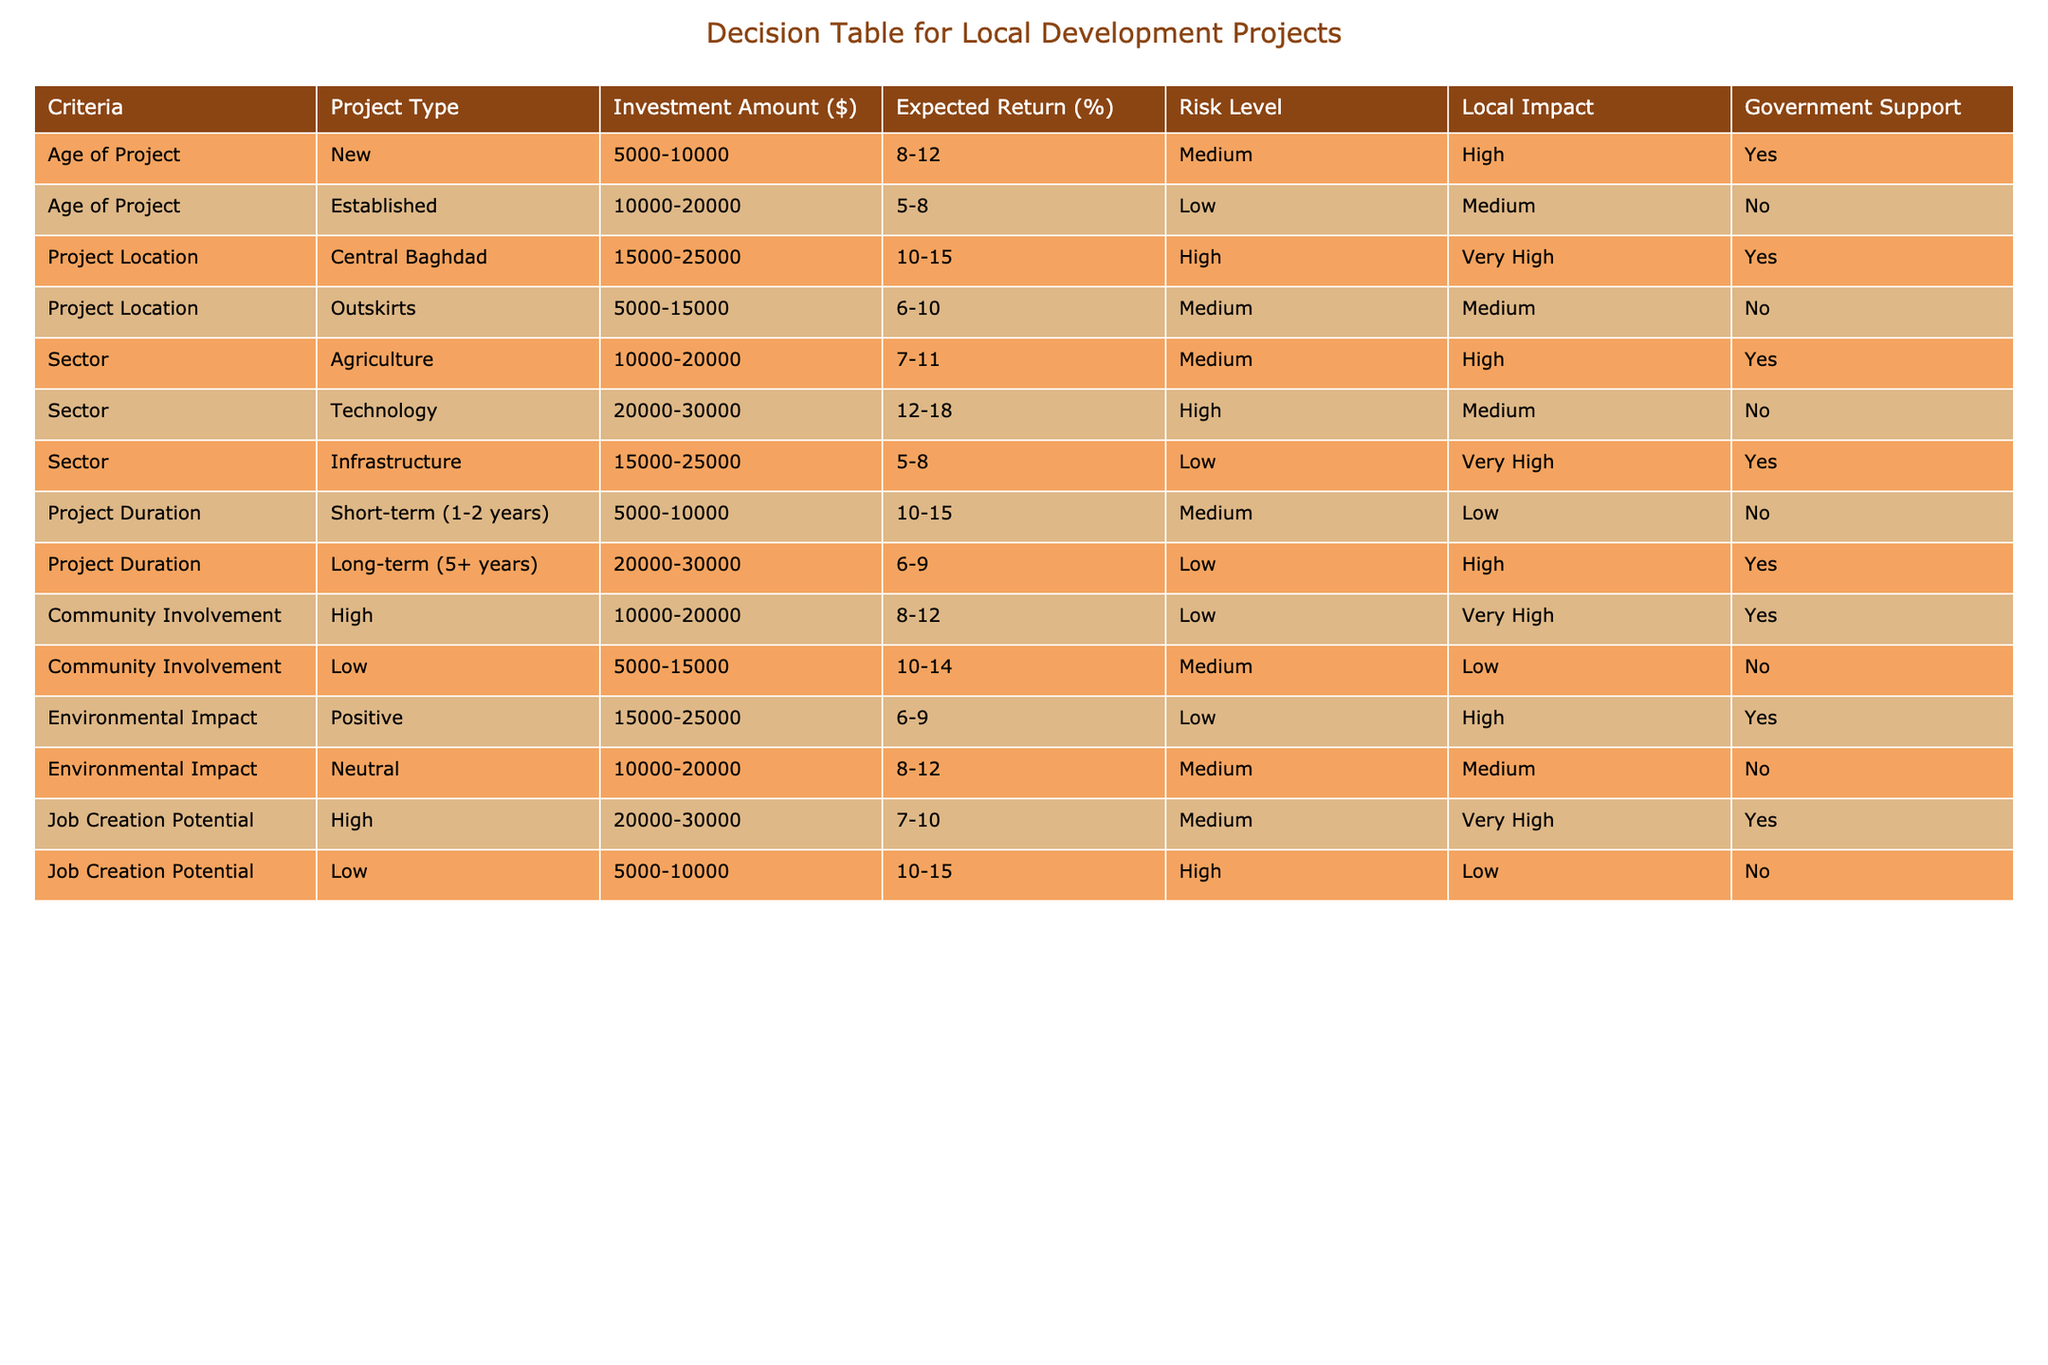What is the expected return for established projects? The table shows that for established projects, the expected return is between 5-8%. This information can be found directly in the “Expected Return (%)” column corresponding to the “Established” row.
Answer: 5-8% Which project type has the lowest risk level? Looking at the “Risk Level” column, the established project type has a low risk level, while all other types generally have medium or high risk levels. This conclusion is drawn from the comparison of risk levels for all project types listed.
Answer: Established Is there government support for projects located in the outskirts? The data shows that for projects located in the outskirts, the government support is marked as “No” in the “Government Support” column. This is directly referenced from the row corresponding to “Outskirts.”
Answer: No What is the average expected return for projects with high community involvement? There are two project types listed with high community involvement: one has an expected return of 8-12% and the other has 6-9%. The average of the ranges can be calculated as follows: the midpoint of 8-12 is 10%, and the midpoint of 6-9 is 7.5%. The average of these two values (10 + 7.5)/2 = 8.75%.
Answer: 8.75% How many project types have a high local impact and receive government support? From the table, we can identify projects that satisfy both conditions. The “New” project type has a high local impact and government support, as does the “Infrastructure” project type. This gives us a total of two project types meeting both criteria.
Answer: 2 What is the maximum investment amount for projects in central Baghdad? Referring to the “Investment Amount ($)” column for the “Central Baghdad” location, we can see it ranges from 15000 to 25000 dollars. The maximum amount within this range is 25000 dollars.
Answer: 25000 What is the risk level for long-term projects? For long-term projects defined as lasting 5 or more years, the table indicates a low risk level. This is found in the “Risk Level” column corresponding to the “Long-term (5+ years)” row.
Answer: Low Are there any project types that can generate a positive environmental impact? The table indicates that there is a row corresponding to positive environmental impact where the “Environmental Impact” is marked as “Positive,” meaning that at least one project can generate such an impact.
Answer: Yes What is the investment range for projects in the technology sector? According to the table, projects within the technology sector require an investment amount ranging from 20000 to 30000 dollars. This information is directly derived from the “Investment Amount ($)” column corresponding to the “Technology” sector row.
Answer: 20000-30000 